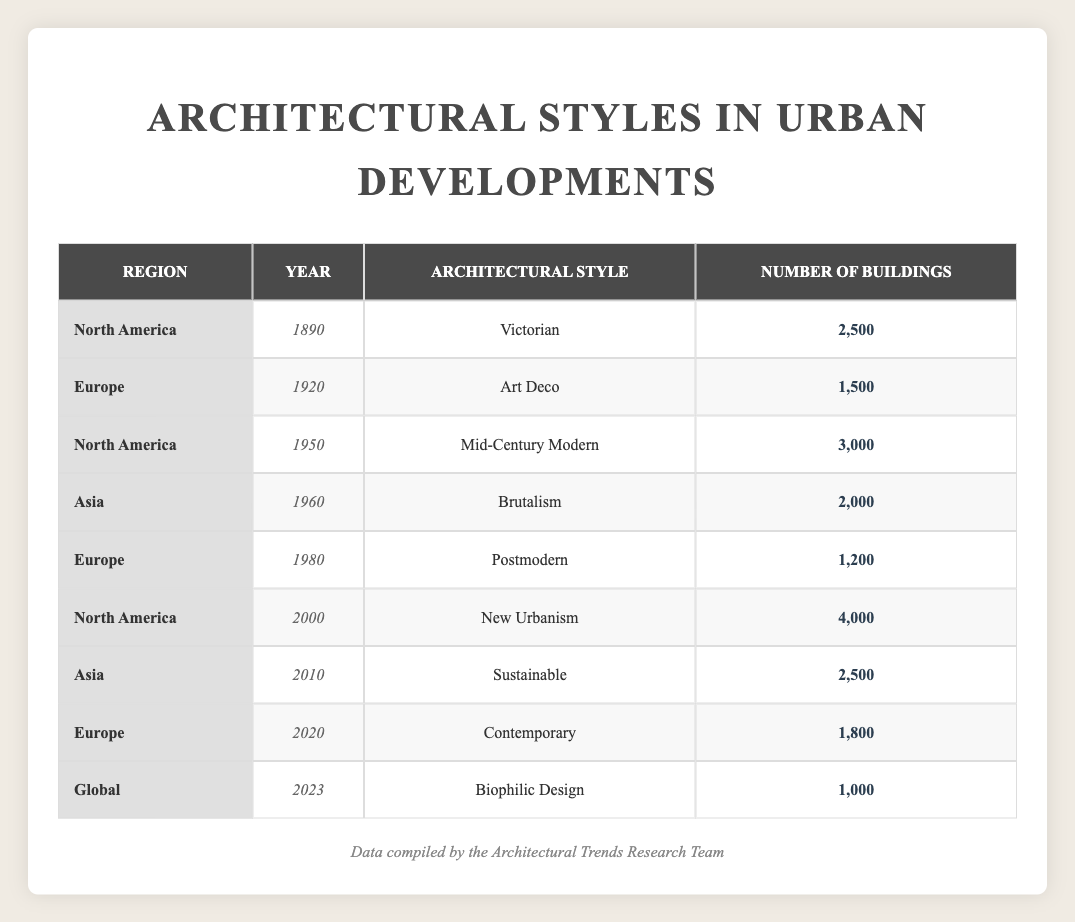What architectural style had the highest number of buildings in North America before 2000? By observing the table, we see the architectural styles listed for North America are Victorian in 1890 with 2,500 buildings, Mid-Century Modern in 1950 with 3,000 buildings, and New Urbanism in 2000 with 4,000 buildings. Out of these, New Urbanism has the highest number (4,000).
Answer: New Urbanism How many buildings were constructed in Europe in 1980? The table shows that in Europe during 1980, the architectural style was Postmodern, with a total of 1,200 buildings.
Answer: 1,200 What was the total number of buildings in Asia from 1960 to 2023? The buildings in Asia are listed as 2,000 in 1960 (Brutalism) and 2,500 in 2010 (Sustainable). Thus, the total amount is calculated as 2,000 + 2,500 = 4,500.
Answer: 4,500 Is there any architectural style listed that falls under the category of "Sustainable"? There is a specific entry for the architectural style "Sustainable" in Asia for the year 2010, which confirms its presence on the table.
Answer: Yes What architectural styles were present in Europe from 1920 to 2020? From the table, in Europe for the years shown, we have Art Deco in 1920, Postmodern in 1980, and Contemporary in 2020. Thus, the styles present in Europe during this period were Art Deco, Postmodern, and Contemporary.
Answer: Art Deco, Postmodern, Contemporary What is the average number of buildings across all regions for the year 2000? The table indicates 4,000 buildings for New Urbanism in North America for the year 2000. Since there are no other entries for 2000, the average is simply 4,000 as there is only one value to consider.
Answer: 4,000 How many buildings were built in North America compared to Europe between 1890 and 2020? In North America, buildings totaled 2,500 (1890, Victorian), 3,000 (1950, Mid-Century Modern), and 4,000 (2000, New Urbanism); this sums to 9,500. For Europe, the total buildings were 1,500 (1920, Art Deco), 1,200 (1980, Postmodern), and 1,800 (2020, Contemporary), totaling 4,500. Therefore, North America had 9,500 while Europe had 4,500, showing North America had more.
Answer: North America: 9,500, Europe: 4,500 Which region had the least number of buildings constructed according to this table? By analyzing the numbers, the least number of buildings (1,000) is recorded for "Biophilic Design" in the Global region for 2023. This suggests that no other entries in the table have a number lower than that in the Global category.
Answer: Global 